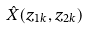<formula> <loc_0><loc_0><loc_500><loc_500>\hat { X } ( z _ { 1 k } , z _ { 2 k } )</formula> 